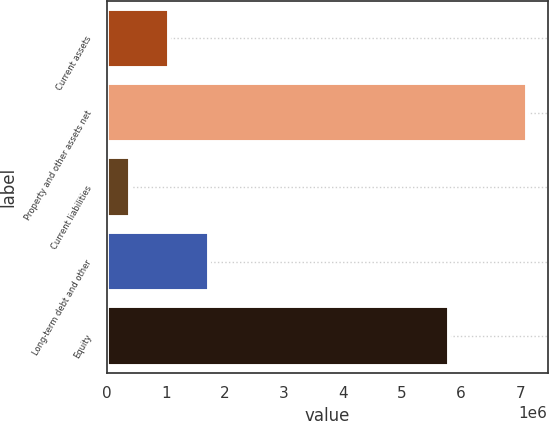Convert chart to OTSL. <chart><loc_0><loc_0><loc_500><loc_500><bar_chart><fcel>Current assets<fcel>Property and other assets net<fcel>Current liabilities<fcel>Long-term debt and other<fcel>Equity<nl><fcel>1.05657e+06<fcel>7.10636e+06<fcel>384370<fcel>1.72877e+06<fcel>5.78605e+06<nl></chart> 